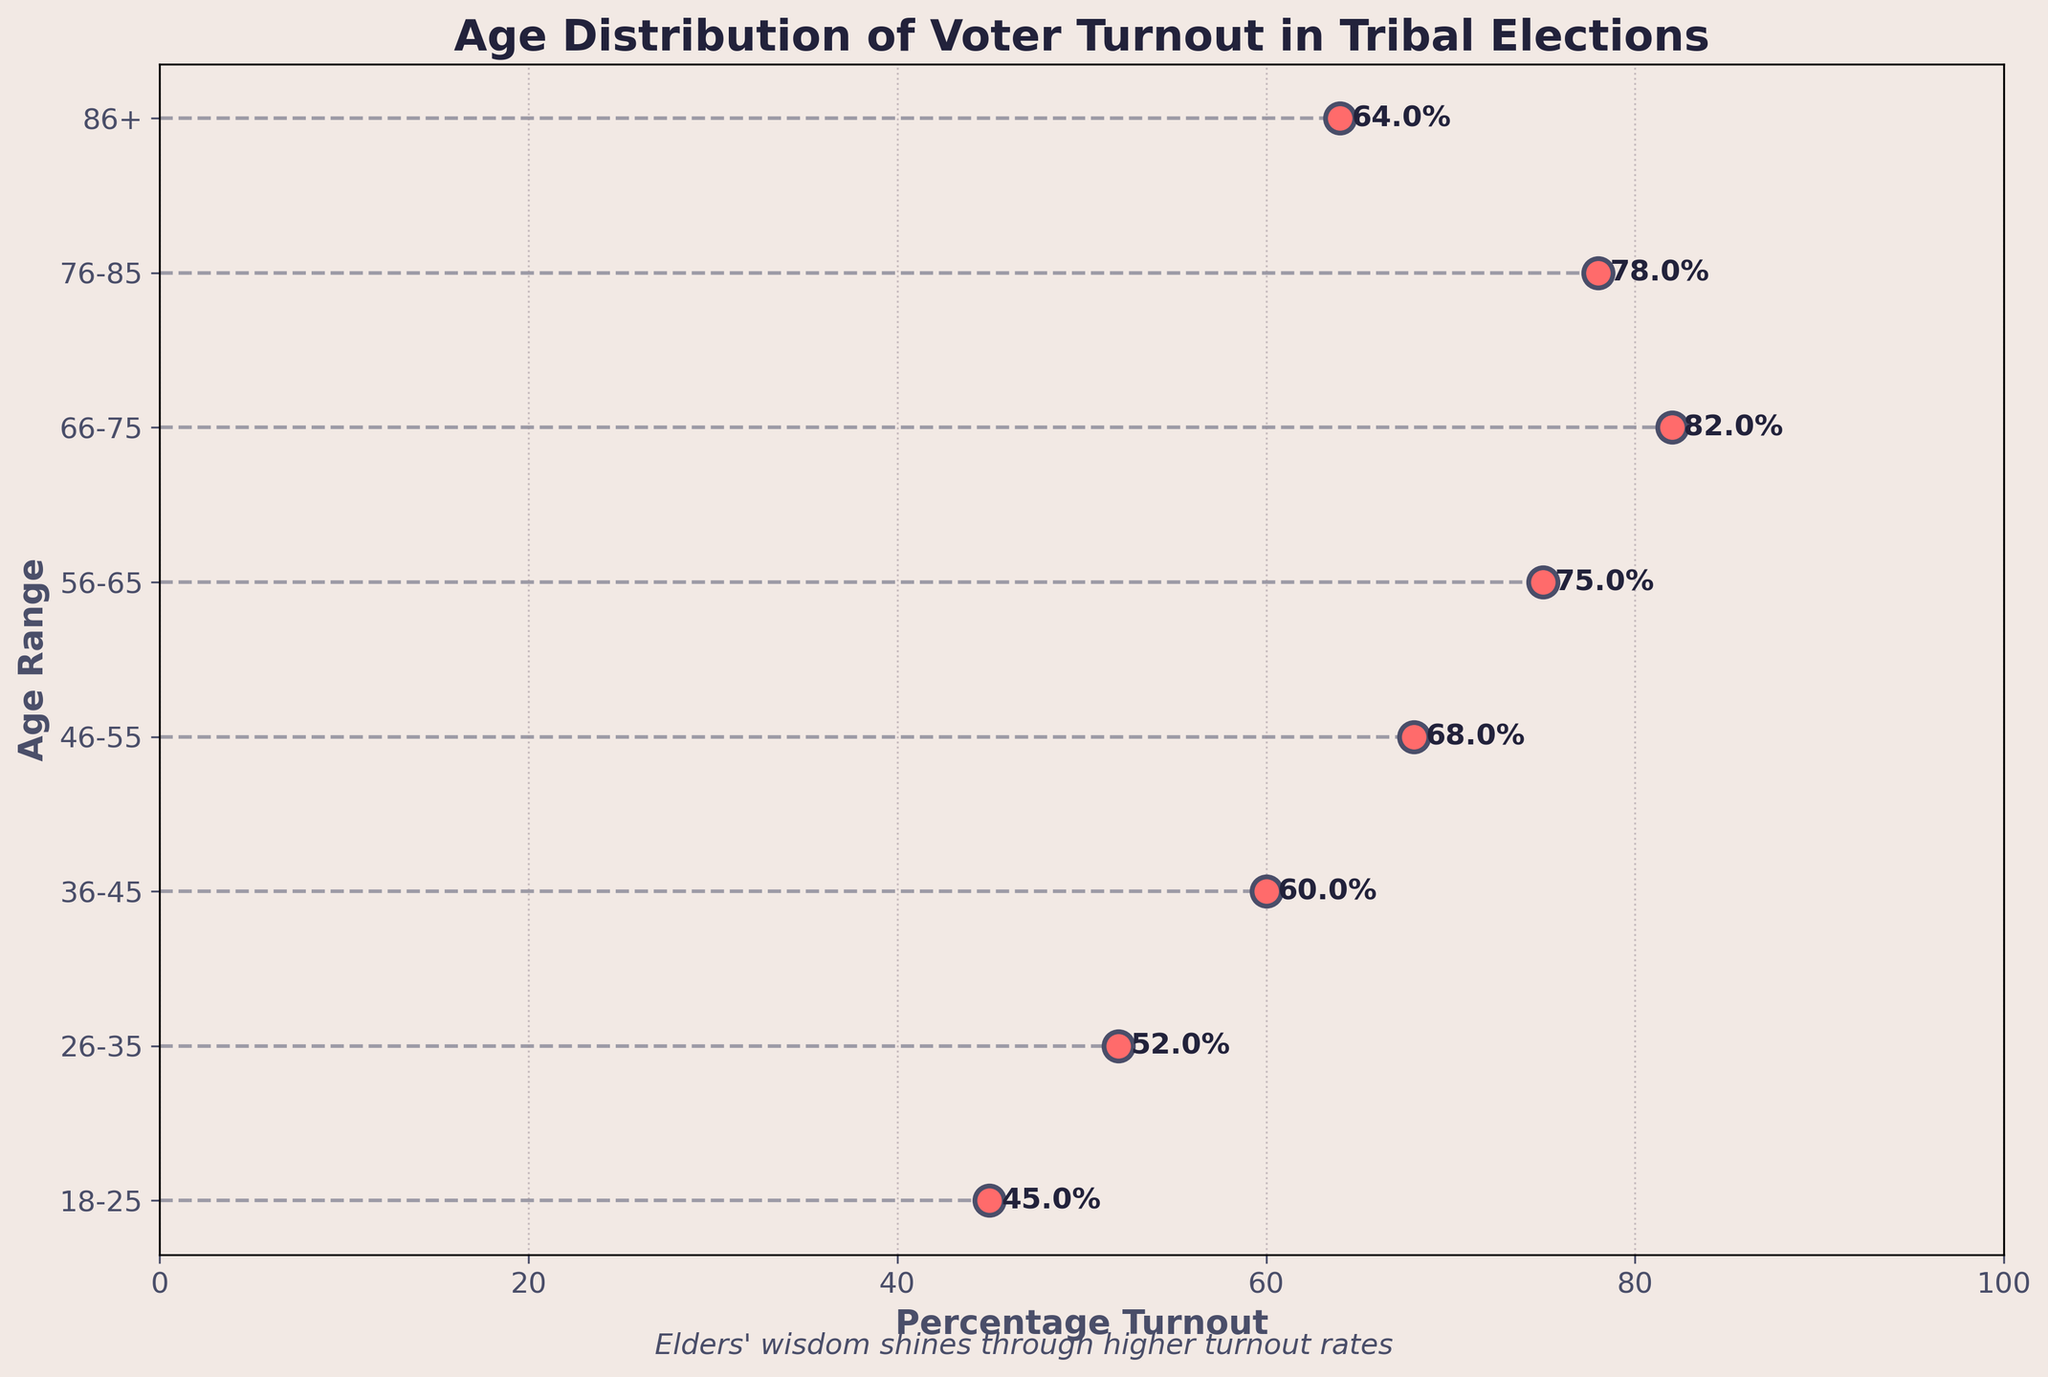What is the title of the plot? The plot's title is displayed on top, centered, and reads "Age Distribution of Voter Turnout in Tribal Elections".
Answer: Age Distribution of Voter Turnout in Tribal Elections What is the percentage turnout for the age range 46-55? The plot shows a dot next to each age range, with the percentage turnout labeled. The dot for the age range 46-55 has a label of "68%".
Answer: 68% Which age range has the highest voter turnout? By looking at the labeled percentages next to each dot, the age range with the highest turnout is the one with the largest percentage label. The 66-75 age range shows an 82% turnout.
Answer: 66-75 What is the difference between the voter turnout of ages 18-25 and 66-75? To find the difference, subtract the turnout percentage of 18-25 from that of 66-75: 82% - 45% = 37%.
Answer: 37% How many age ranges have a voter turnout of 75% or more? Examine the plot and count the number of dots with percentage labels of 75% or greater. The age ranges 56-65 (75%), 66-75 (82%), and 76-85 (78%) meet this criterion.
Answer: 3 What age range shows a voter turnout decrease compared to its preceding range? By comparing each age range's turnout percentage to its preceding range, the age range 76-85 shows a decrease (78%) compared to 66-75 (82%).
Answer: 76-85 What's the average voter turnout for individuals aged 56 and above? Calculate the average for age ranges 56-65, 66-75, 76-85, and 86+: (75% + 82% + 78% + 64%) / 4 = 299% / 4 = 74.75%.
Answer: 74.75% Which age range has the most significant increase in voter turnout compared to the 18-25 range? Compare the percentage increase in each subsequent range to the 18-25 range (45%). The largest increase is between 18-25 and 66-75, which is 82% - 45% = 37%.
Answer: 66-75 Is the voter turnout generally higher for older or younger voters? By comparing the trends in the plot, it is visible that the voter turnout generally increases with age until 66-75, then slightly decreases but still remains high compared to the younger groups.
Answer: Older 